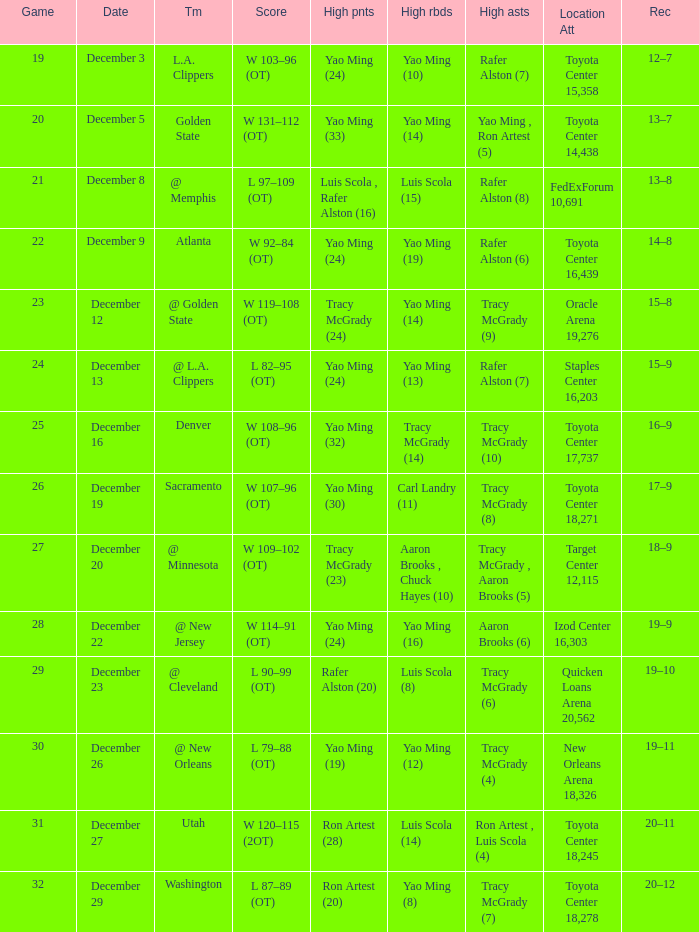When tracy mcgrady (8) is leading in assists what is the date? December 19. 